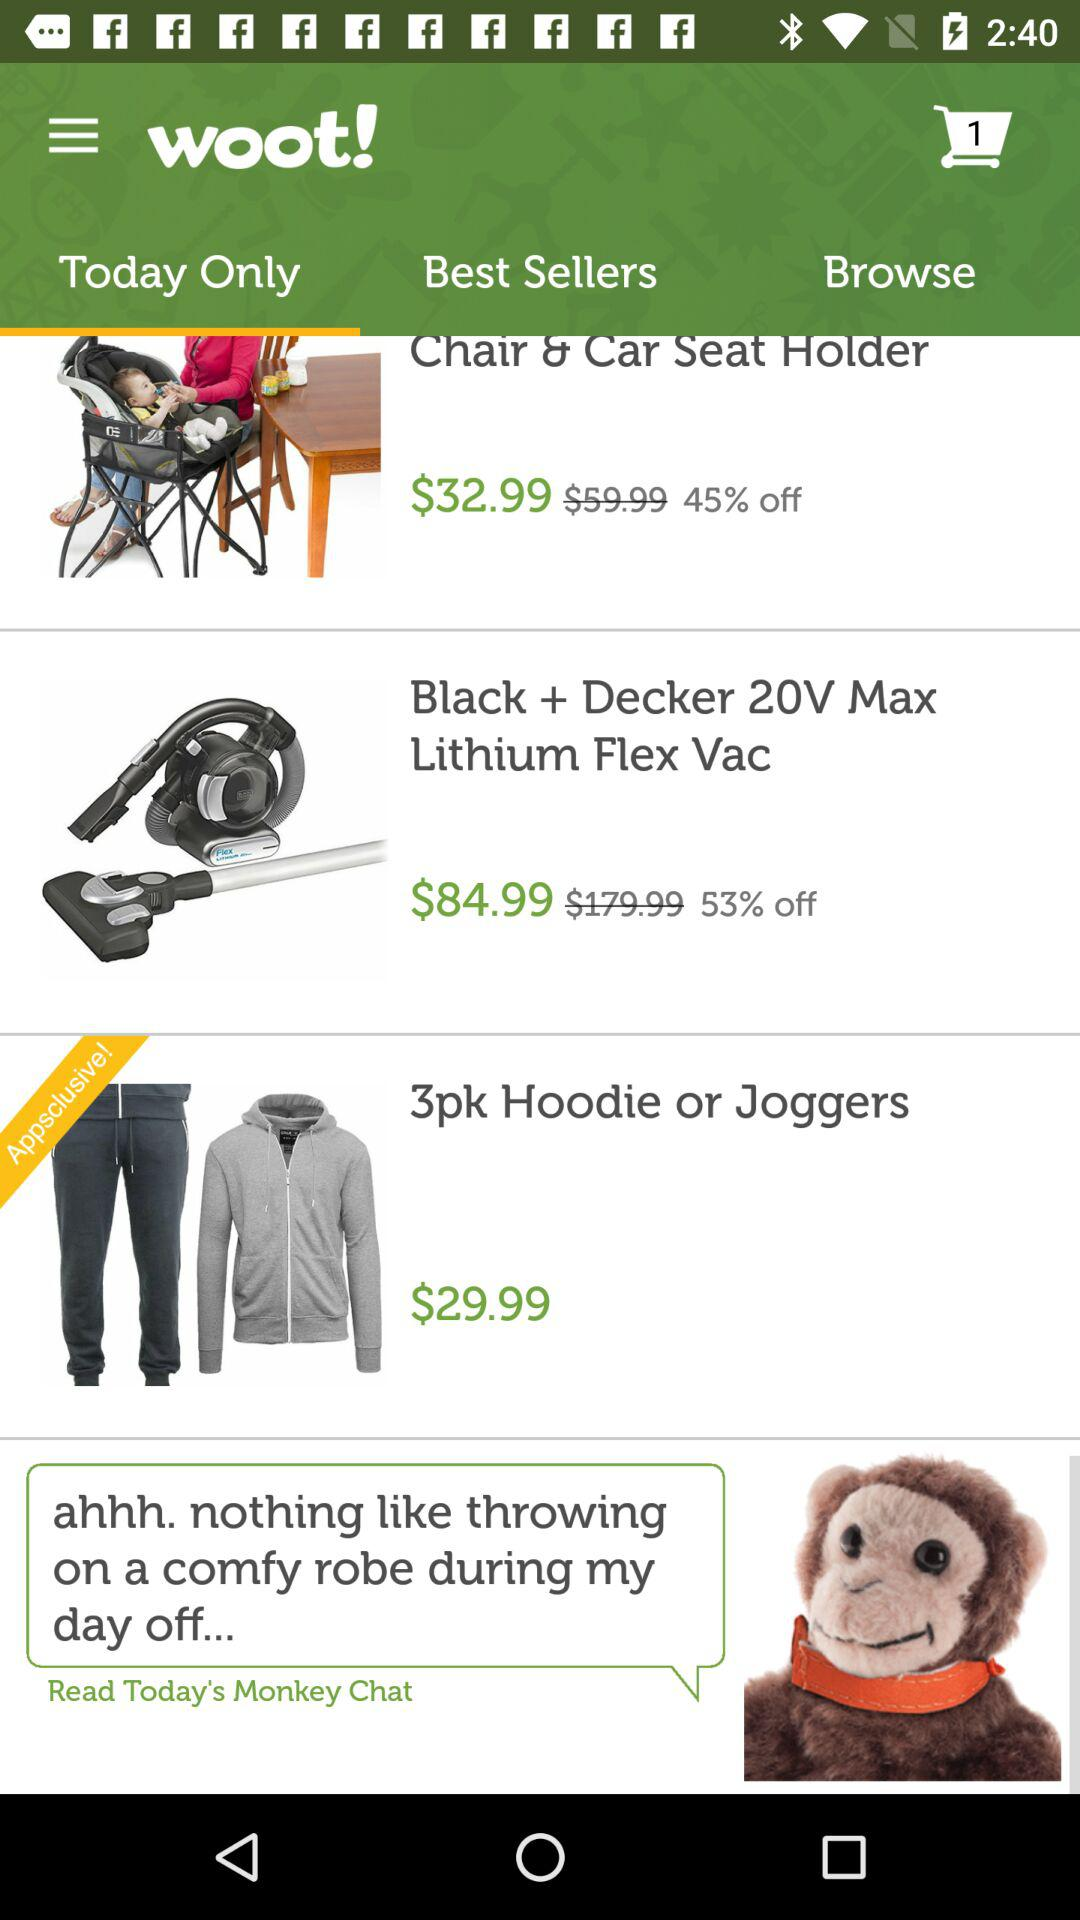How many items are in the cart? The item in the cart is 1. 